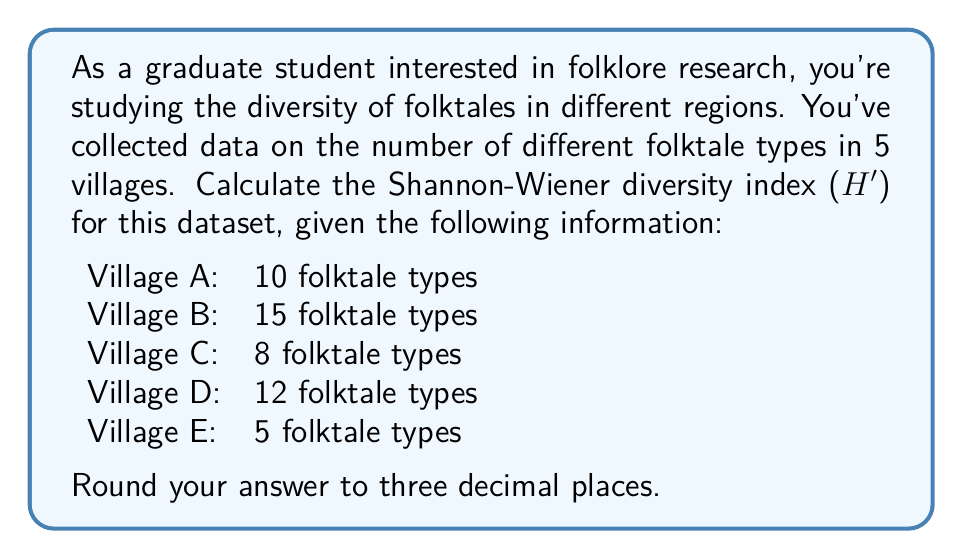Provide a solution to this math problem. The Shannon-Wiener diversity index (H') is a measure of biodiversity that takes into account both the number of species (or in this case, folktale types) and their relative abundances. It's calculated using the formula:

$$H' = -\sum_{i=1}^{R} p_i \ln(p_i)$$

Where:
- $R$ is the number of different types (in this case, the number of villages)
- $p_i$ is the proportion of individuals belonging to the $i$-th type

Step 1: Calculate the total number of folktale types.
Total = 10 + 15 + 8 + 12 + 5 = 50

Step 2: Calculate the proportion ($p_i$) for each village.
$p_A = 10/50 = 0.2$
$p_B = 15/50 = 0.3$
$p_C = 8/50 = 0.16$
$p_D = 12/50 = 0.24$
$p_E = 5/50 = 0.1$

Step 3: Calculate $p_i \ln(p_i)$ for each village.
Village A: $0.2 \ln(0.2) = -0.321887582$
Village B: $0.3 \ln(0.3) = -0.361191556$
Village C: $0.16 \ln(0.16) = -0.293763208$
Village D: $0.24 \ln(0.24) = -0.343780502$
Village E: $0.1 \ln(0.1) = -0.230258509$

Step 4: Sum the negative values of these results.
$H' = -(-0.321887582 + -0.361191556 + -0.293763208 + -0.343780502 + -0.230258509)$

Step 5: Calculate the final result.
$H' = 1.550881357$

Step 6: Round to three decimal places.
$H' = 1.551$
Answer: 1.551 